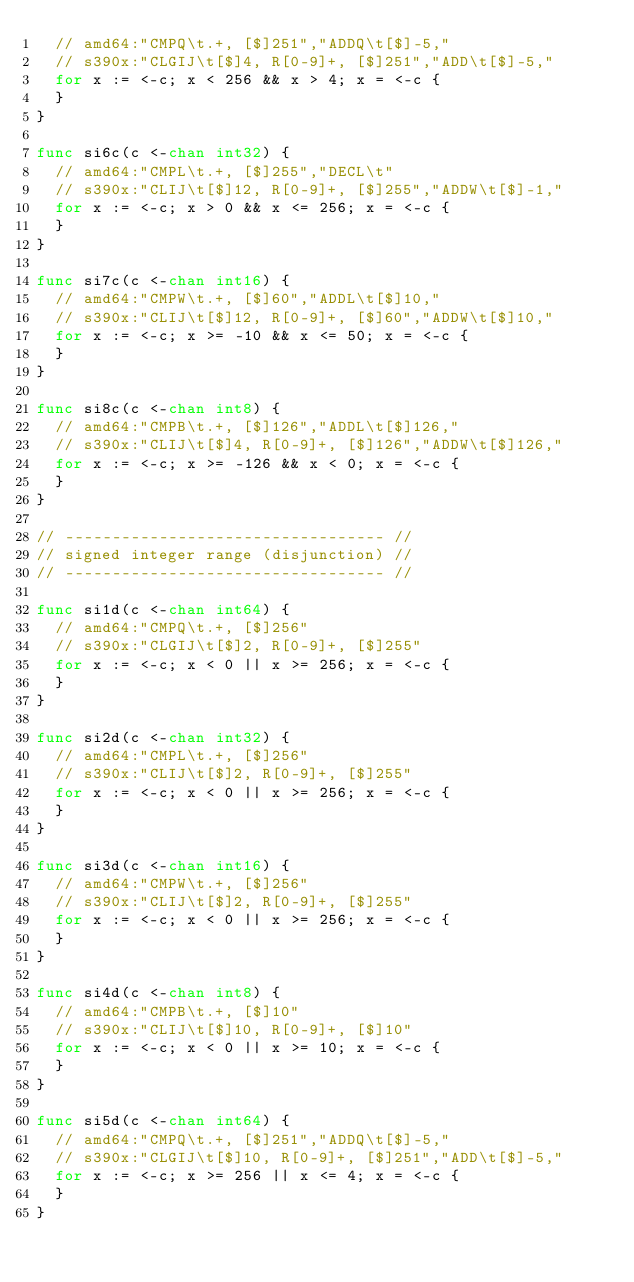<code> <loc_0><loc_0><loc_500><loc_500><_Go_>	// amd64:"CMPQ\t.+, [$]251","ADDQ\t[$]-5,"
	// s390x:"CLGIJ\t[$]4, R[0-9]+, [$]251","ADD\t[$]-5,"
	for x := <-c; x < 256 && x > 4; x = <-c {
	}
}

func si6c(c <-chan int32) {
	// amd64:"CMPL\t.+, [$]255","DECL\t"
	// s390x:"CLIJ\t[$]12, R[0-9]+, [$]255","ADDW\t[$]-1,"
	for x := <-c; x > 0 && x <= 256; x = <-c {
	}
}

func si7c(c <-chan int16) {
	// amd64:"CMPW\t.+, [$]60","ADDL\t[$]10,"
	// s390x:"CLIJ\t[$]12, R[0-9]+, [$]60","ADDW\t[$]10,"
	for x := <-c; x >= -10 && x <= 50; x = <-c {
	}
}

func si8c(c <-chan int8) {
	// amd64:"CMPB\t.+, [$]126","ADDL\t[$]126,"
	// s390x:"CLIJ\t[$]4, R[0-9]+, [$]126","ADDW\t[$]126,"
	for x := <-c; x >= -126 && x < 0; x = <-c {
	}
}

// ---------------------------------- //
// signed integer range (disjunction) //
// ---------------------------------- //

func si1d(c <-chan int64) {
	// amd64:"CMPQ\t.+, [$]256"
	// s390x:"CLGIJ\t[$]2, R[0-9]+, [$]255"
	for x := <-c; x < 0 || x >= 256; x = <-c {
	}
}

func si2d(c <-chan int32) {
	// amd64:"CMPL\t.+, [$]256"
	// s390x:"CLIJ\t[$]2, R[0-9]+, [$]255"
	for x := <-c; x < 0 || x >= 256; x = <-c {
	}
}

func si3d(c <-chan int16) {
	// amd64:"CMPW\t.+, [$]256"
	// s390x:"CLIJ\t[$]2, R[0-9]+, [$]255"
	for x := <-c; x < 0 || x >= 256; x = <-c {
	}
}

func si4d(c <-chan int8) {
	// amd64:"CMPB\t.+, [$]10"
	// s390x:"CLIJ\t[$]10, R[0-9]+, [$]10"
	for x := <-c; x < 0 || x >= 10; x = <-c {
	}
}

func si5d(c <-chan int64) {
	// amd64:"CMPQ\t.+, [$]251","ADDQ\t[$]-5,"
	// s390x:"CLGIJ\t[$]10, R[0-9]+, [$]251","ADD\t[$]-5,"
	for x := <-c; x >= 256 || x <= 4; x = <-c {
	}
}
</code> 